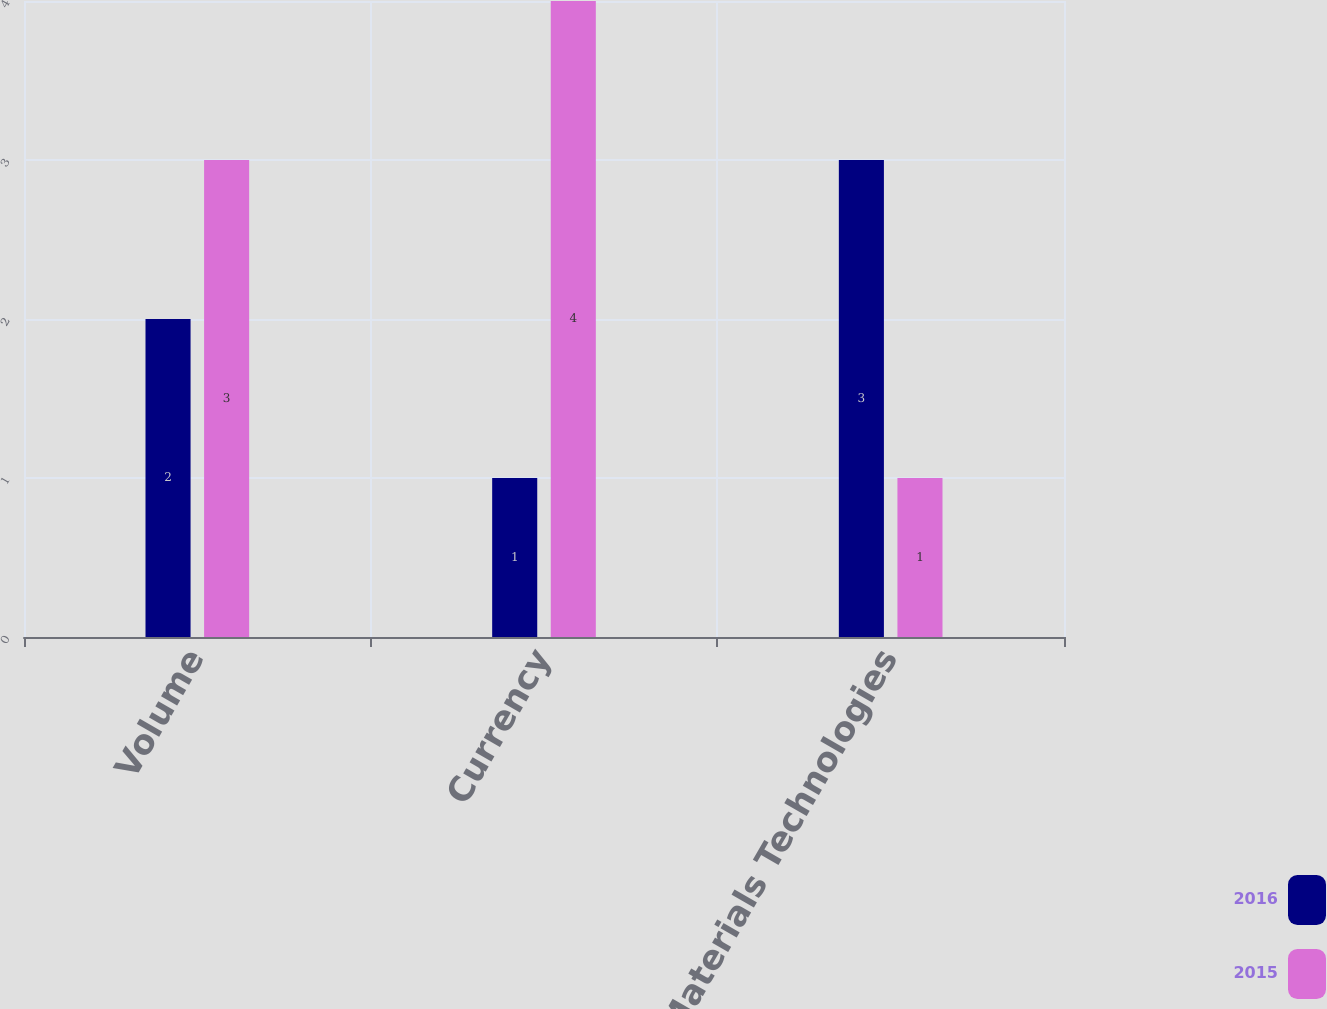Convert chart. <chart><loc_0><loc_0><loc_500><loc_500><stacked_bar_chart><ecel><fcel>Volume<fcel>Currency<fcel>Total Materials Technologies<nl><fcel>2016<fcel>2<fcel>1<fcel>3<nl><fcel>2015<fcel>3<fcel>4<fcel>1<nl></chart> 